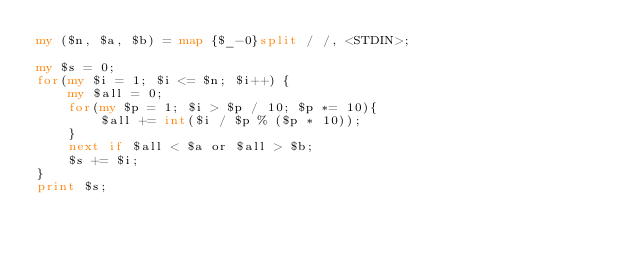<code> <loc_0><loc_0><loc_500><loc_500><_Perl_>my ($n, $a, $b) = map {$_-0}split / /, <STDIN>;

my $s = 0;
for(my $i = 1; $i <= $n; $i++) {
    my $all = 0;
    for(my $p = 1; $i > $p / 10; $p *= 10){
        $all += int($i / $p % ($p * 10));
    }
    next if $all < $a or $all > $b;
    $s += $i;
}
print $s;</code> 